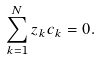<formula> <loc_0><loc_0><loc_500><loc_500>\sum _ { k = 1 } ^ { N } z _ { k } c _ { k } = 0 .</formula> 